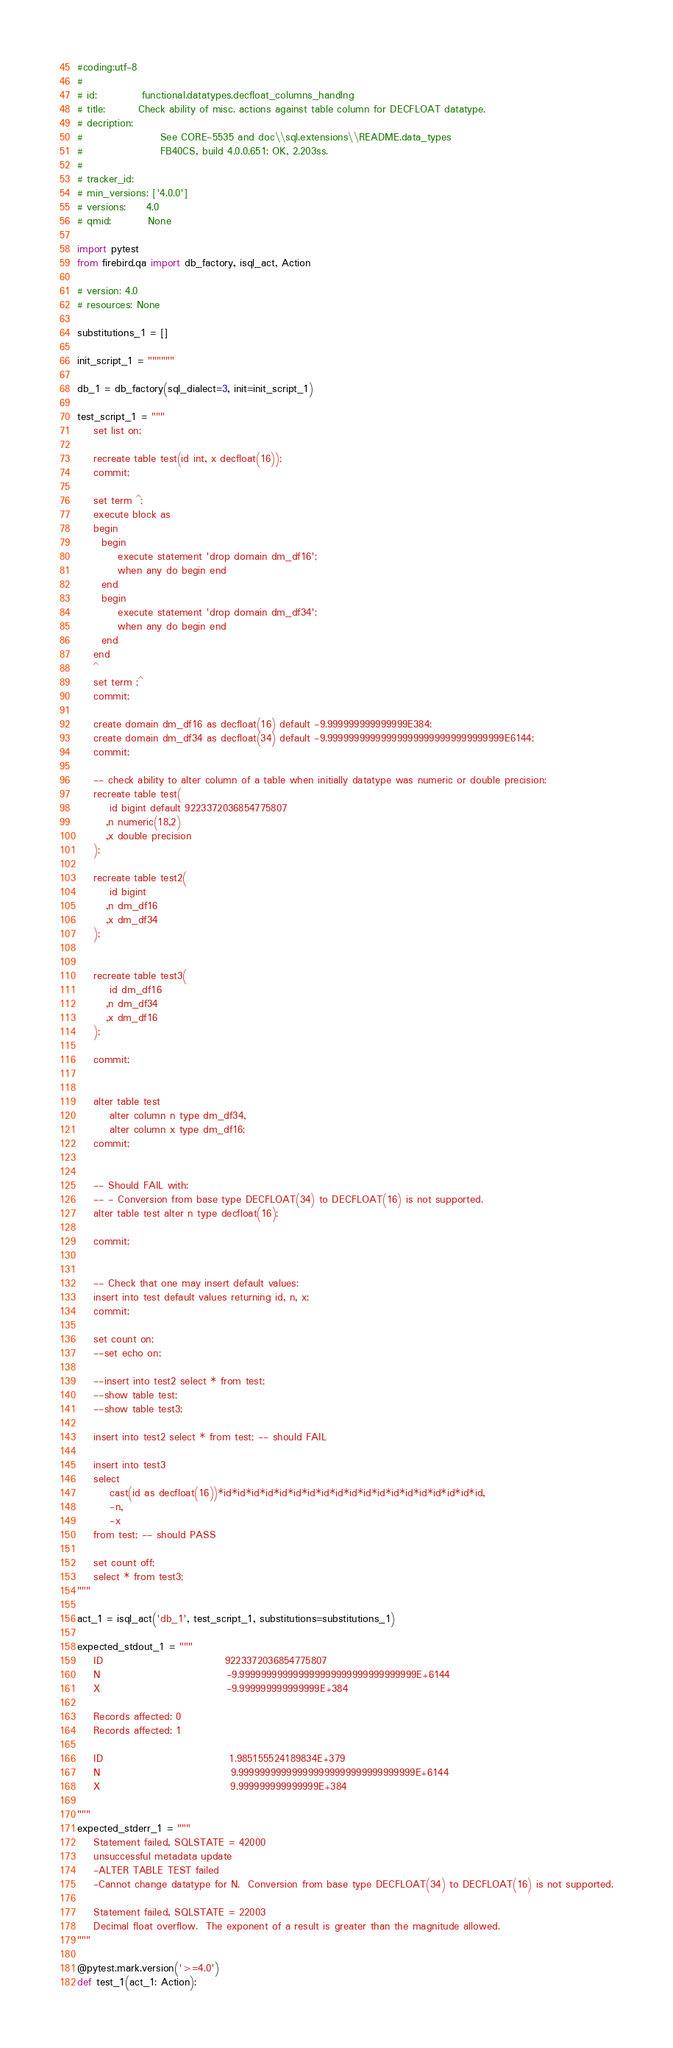<code> <loc_0><loc_0><loc_500><loc_500><_Python_>#coding:utf-8
#
# id:           functional.datatypes.decfloat_columns_handlng
# title:        Check ability of misc. actions against table column for DECFLOAT datatype.
# decription:   
#                   See CORE-5535 and doc\\sql.extensions\\README.data_types
#                   FB40CS, build 4.0.0.651: OK, 2.203ss.
#                
# tracker_id:   
# min_versions: ['4.0.0']
# versions:     4.0
# qmid:         None

import pytest
from firebird.qa import db_factory, isql_act, Action

# version: 4.0
# resources: None

substitutions_1 = []

init_script_1 = """"""

db_1 = db_factory(sql_dialect=3, init=init_script_1)

test_script_1 = """
    set list on;

    recreate table test(id int, x decfloat(16));
    commit;

    set term ^;
    execute block as
    begin
      begin
          execute statement 'drop domain dm_df16';
          when any do begin end
      end
      begin
          execute statement 'drop domain dm_df34';
          when any do begin end
      end
    end
    ^
    set term ;^
    commit;

    create domain dm_df16 as decfloat(16) default -9.999999999999999E384;
    create domain dm_df34 as decfloat(34) default -9.999999999999999999999999999999999E6144;
    commit;

    -- check ability to alter column of a table when initially datatype was numeric or double precision:
    recreate table test(
        id bigint default 9223372036854775807
       ,n numeric(18,2)
       ,x double precision
    );

    recreate table test2(
        id bigint
       ,n dm_df16
       ,x dm_df34
    );


    recreate table test3(
        id dm_df16
       ,n dm_df34
       ,x dm_df16
    );

    commit;


    alter table test
        alter column n type dm_df34,
        alter column x type dm_df16;
    commit;


    -- Should FAIL with:
    -- - Conversion from base type DECFLOAT(34) to DECFLOAT(16) is not supported.
    alter table test alter n type decfloat(16);

    commit;


    -- Check that one may insert default values:
    insert into test default values returning id, n, x;
    commit;

    set count on;
    --set echo on;

    --insert into test2 select * from test;
    --show table test;
    --show table test3;

    insert into test2 select * from test; -- should FAIL

    insert into test3 
    select 
        cast(id as decfloat(16))*id*id*id*id*id*id*id*id*id*id*id*id*id*id*id*id*id*id*id, 
        -n, 
        -x 
    from test; -- should PASS

    set count off;
    select * from test3;
"""

act_1 = isql_act('db_1', test_script_1, substitutions=substitutions_1)

expected_stdout_1 = """
    ID                              9223372036854775807
    N                               -9.999999999999999999999999999999999E+6144
    X                               -9.999999999999999E+384

    Records affected: 0
    Records affected: 1

    ID                               1.985155524189834E+379
    N                                9.999999999999999999999999999999999E+6144
    X                                9.999999999999999E+384

"""
expected_stderr_1 = """
    Statement failed, SQLSTATE = 42000
    unsuccessful metadata update
    -ALTER TABLE TEST failed
    -Cannot change datatype for N.  Conversion from base type DECFLOAT(34) to DECFLOAT(16) is not supported.

    Statement failed, SQLSTATE = 22003
    Decimal float overflow.  The exponent of a result is greater than the magnitude allowed.
"""

@pytest.mark.version('>=4.0')
def test_1(act_1: Action):</code> 